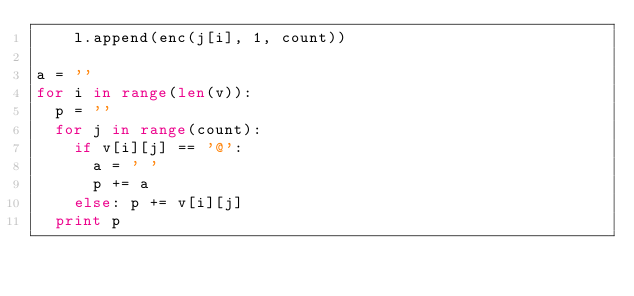Convert code to text. <code><loc_0><loc_0><loc_500><loc_500><_Python_>		l.append(enc(j[i], 1, count))

a = ''
for i in range(len(v)):
	p = ''
	for j in range(count):
		if v[i][j] == '@':
			a = ' '
			p += a
		else: p += v[i][j]
	print p

</code> 